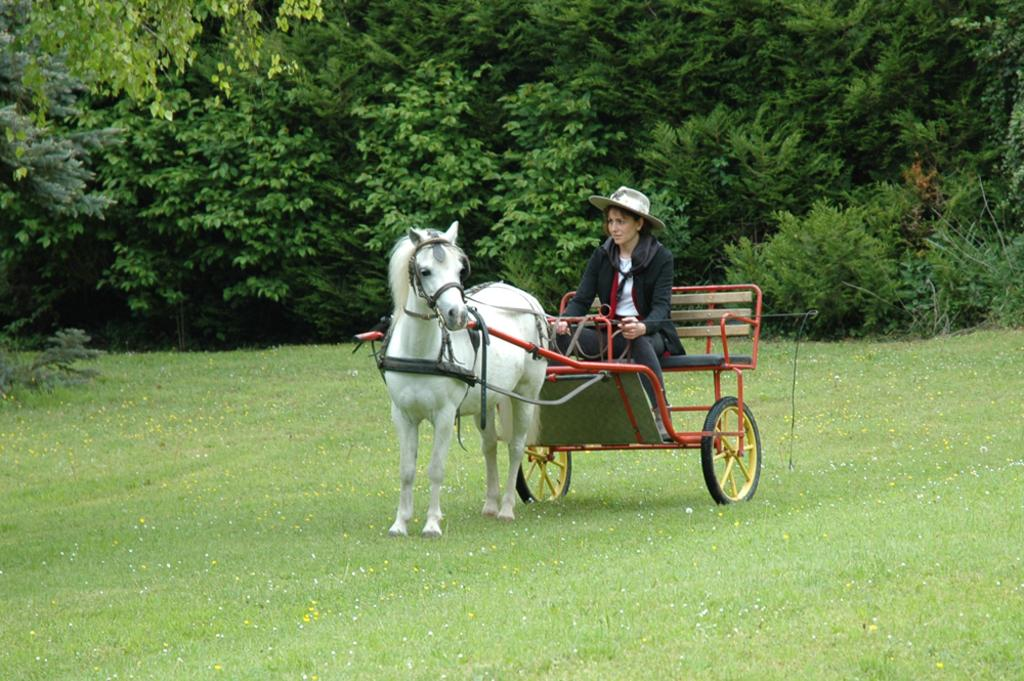Who is present in the image? There is a woman in the image. What is the woman doing in the image? The woman is sitting in a horse cart. What type of vegetation is visible at the bottom of the image? There is grass at the bottom of the image. What can be seen in the background of the image? There are trees in the background of the image. What is the woman wearing on her head? The woman is wearing a cap. What type of honey is being produced by the bees in the image? There are no bees or honey present in the image; it features a woman sitting in a horse cart with grass and trees in the background. 